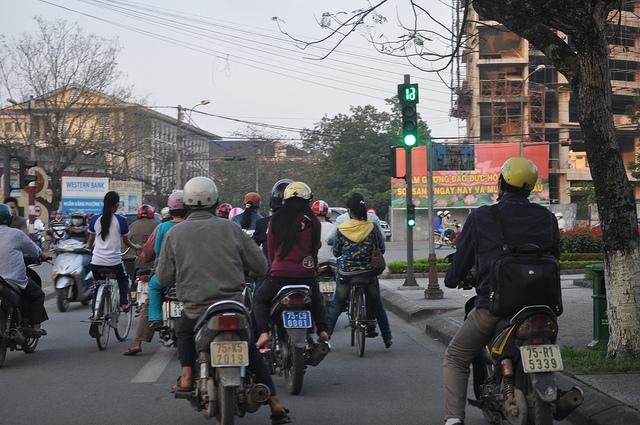What country is this street scene likely part of? Please explain your reasoning. vietnam. The country is likely vietnam because the writing is in vietnamese. 